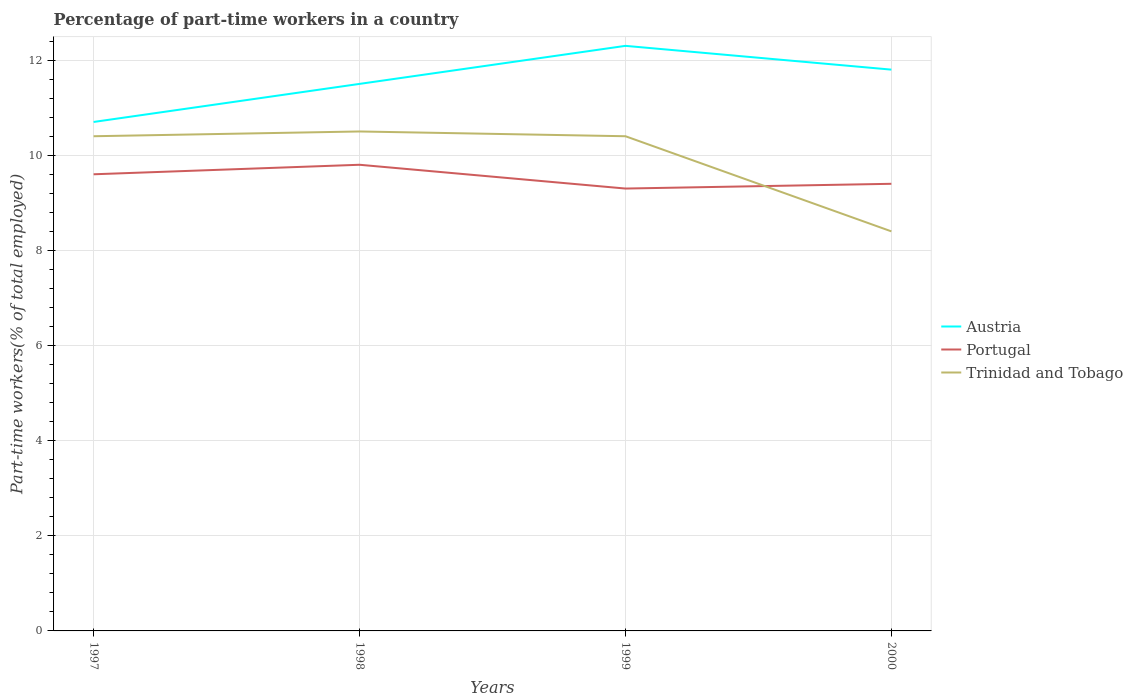How many different coloured lines are there?
Offer a very short reply. 3. Does the line corresponding to Trinidad and Tobago intersect with the line corresponding to Portugal?
Offer a terse response. Yes. Is the number of lines equal to the number of legend labels?
Provide a succinct answer. Yes. Across all years, what is the maximum percentage of part-time workers in Portugal?
Offer a terse response. 9.3. In which year was the percentage of part-time workers in Trinidad and Tobago maximum?
Your response must be concise. 2000. What is the total percentage of part-time workers in Portugal in the graph?
Ensure brevity in your answer.  0.2. What is the difference between the highest and the second highest percentage of part-time workers in Austria?
Offer a terse response. 1.6. Is the percentage of part-time workers in Austria strictly greater than the percentage of part-time workers in Trinidad and Tobago over the years?
Offer a very short reply. No. How many lines are there?
Offer a very short reply. 3. How many years are there in the graph?
Offer a very short reply. 4. How are the legend labels stacked?
Your response must be concise. Vertical. What is the title of the graph?
Provide a succinct answer. Percentage of part-time workers in a country. Does "Guam" appear as one of the legend labels in the graph?
Your answer should be very brief. No. What is the label or title of the X-axis?
Provide a succinct answer. Years. What is the label or title of the Y-axis?
Your answer should be compact. Part-time workers(% of total employed). What is the Part-time workers(% of total employed) of Austria in 1997?
Keep it short and to the point. 10.7. What is the Part-time workers(% of total employed) of Portugal in 1997?
Give a very brief answer. 9.6. What is the Part-time workers(% of total employed) of Trinidad and Tobago in 1997?
Offer a terse response. 10.4. What is the Part-time workers(% of total employed) of Austria in 1998?
Your answer should be very brief. 11.5. What is the Part-time workers(% of total employed) of Portugal in 1998?
Offer a very short reply. 9.8. What is the Part-time workers(% of total employed) in Trinidad and Tobago in 1998?
Provide a short and direct response. 10.5. What is the Part-time workers(% of total employed) of Austria in 1999?
Provide a succinct answer. 12.3. What is the Part-time workers(% of total employed) in Portugal in 1999?
Offer a terse response. 9.3. What is the Part-time workers(% of total employed) in Trinidad and Tobago in 1999?
Provide a short and direct response. 10.4. What is the Part-time workers(% of total employed) in Austria in 2000?
Ensure brevity in your answer.  11.8. What is the Part-time workers(% of total employed) in Portugal in 2000?
Make the answer very short. 9.4. What is the Part-time workers(% of total employed) of Trinidad and Tobago in 2000?
Make the answer very short. 8.4. Across all years, what is the maximum Part-time workers(% of total employed) of Austria?
Keep it short and to the point. 12.3. Across all years, what is the maximum Part-time workers(% of total employed) in Portugal?
Provide a succinct answer. 9.8. Across all years, what is the maximum Part-time workers(% of total employed) of Trinidad and Tobago?
Offer a terse response. 10.5. Across all years, what is the minimum Part-time workers(% of total employed) in Austria?
Keep it short and to the point. 10.7. Across all years, what is the minimum Part-time workers(% of total employed) of Portugal?
Ensure brevity in your answer.  9.3. Across all years, what is the minimum Part-time workers(% of total employed) of Trinidad and Tobago?
Your response must be concise. 8.4. What is the total Part-time workers(% of total employed) of Austria in the graph?
Give a very brief answer. 46.3. What is the total Part-time workers(% of total employed) of Portugal in the graph?
Provide a succinct answer. 38.1. What is the total Part-time workers(% of total employed) in Trinidad and Tobago in the graph?
Your answer should be compact. 39.7. What is the difference between the Part-time workers(% of total employed) in Austria in 1997 and that in 1998?
Ensure brevity in your answer.  -0.8. What is the difference between the Part-time workers(% of total employed) in Austria in 1997 and that in 1999?
Make the answer very short. -1.6. What is the difference between the Part-time workers(% of total employed) in Portugal in 1997 and that in 1999?
Offer a very short reply. 0.3. What is the difference between the Part-time workers(% of total employed) of Trinidad and Tobago in 1997 and that in 1999?
Make the answer very short. 0. What is the difference between the Part-time workers(% of total employed) of Austria in 1997 and that in 2000?
Offer a very short reply. -1.1. What is the difference between the Part-time workers(% of total employed) in Austria in 1998 and that in 1999?
Ensure brevity in your answer.  -0.8. What is the difference between the Part-time workers(% of total employed) in Trinidad and Tobago in 1998 and that in 2000?
Your answer should be very brief. 2.1. What is the difference between the Part-time workers(% of total employed) of Portugal in 1999 and that in 2000?
Provide a succinct answer. -0.1. What is the difference between the Part-time workers(% of total employed) of Trinidad and Tobago in 1999 and that in 2000?
Ensure brevity in your answer.  2. What is the difference between the Part-time workers(% of total employed) of Austria in 1997 and the Part-time workers(% of total employed) of Trinidad and Tobago in 1999?
Your response must be concise. 0.3. What is the difference between the Part-time workers(% of total employed) in Austria in 1997 and the Part-time workers(% of total employed) in Portugal in 2000?
Your answer should be very brief. 1.3. What is the difference between the Part-time workers(% of total employed) in Austria in 1997 and the Part-time workers(% of total employed) in Trinidad and Tobago in 2000?
Make the answer very short. 2.3. What is the difference between the Part-time workers(% of total employed) in Austria in 1998 and the Part-time workers(% of total employed) in Trinidad and Tobago in 2000?
Make the answer very short. 3.1. What is the difference between the Part-time workers(% of total employed) of Portugal in 1998 and the Part-time workers(% of total employed) of Trinidad and Tobago in 2000?
Your answer should be compact. 1.4. What is the difference between the Part-time workers(% of total employed) of Austria in 1999 and the Part-time workers(% of total employed) of Portugal in 2000?
Offer a terse response. 2.9. What is the difference between the Part-time workers(% of total employed) in Portugal in 1999 and the Part-time workers(% of total employed) in Trinidad and Tobago in 2000?
Give a very brief answer. 0.9. What is the average Part-time workers(% of total employed) of Austria per year?
Your answer should be compact. 11.57. What is the average Part-time workers(% of total employed) of Portugal per year?
Make the answer very short. 9.53. What is the average Part-time workers(% of total employed) in Trinidad and Tobago per year?
Offer a very short reply. 9.93. In the year 1997, what is the difference between the Part-time workers(% of total employed) of Austria and Part-time workers(% of total employed) of Trinidad and Tobago?
Offer a terse response. 0.3. In the year 1998, what is the difference between the Part-time workers(% of total employed) in Austria and Part-time workers(% of total employed) in Portugal?
Provide a short and direct response. 1.7. In the year 1999, what is the difference between the Part-time workers(% of total employed) of Portugal and Part-time workers(% of total employed) of Trinidad and Tobago?
Provide a short and direct response. -1.1. In the year 2000, what is the difference between the Part-time workers(% of total employed) in Austria and Part-time workers(% of total employed) in Portugal?
Your answer should be compact. 2.4. What is the ratio of the Part-time workers(% of total employed) of Austria in 1997 to that in 1998?
Keep it short and to the point. 0.93. What is the ratio of the Part-time workers(% of total employed) in Portugal in 1997 to that in 1998?
Keep it short and to the point. 0.98. What is the ratio of the Part-time workers(% of total employed) in Trinidad and Tobago in 1997 to that in 1998?
Keep it short and to the point. 0.99. What is the ratio of the Part-time workers(% of total employed) in Austria in 1997 to that in 1999?
Make the answer very short. 0.87. What is the ratio of the Part-time workers(% of total employed) in Portugal in 1997 to that in 1999?
Keep it short and to the point. 1.03. What is the ratio of the Part-time workers(% of total employed) of Trinidad and Tobago in 1997 to that in 1999?
Make the answer very short. 1. What is the ratio of the Part-time workers(% of total employed) of Austria in 1997 to that in 2000?
Ensure brevity in your answer.  0.91. What is the ratio of the Part-time workers(% of total employed) in Portugal in 1997 to that in 2000?
Offer a terse response. 1.02. What is the ratio of the Part-time workers(% of total employed) in Trinidad and Tobago in 1997 to that in 2000?
Give a very brief answer. 1.24. What is the ratio of the Part-time workers(% of total employed) of Austria in 1998 to that in 1999?
Give a very brief answer. 0.94. What is the ratio of the Part-time workers(% of total employed) of Portugal in 1998 to that in 1999?
Your response must be concise. 1.05. What is the ratio of the Part-time workers(% of total employed) in Trinidad and Tobago in 1998 to that in 1999?
Provide a short and direct response. 1.01. What is the ratio of the Part-time workers(% of total employed) of Austria in 1998 to that in 2000?
Provide a short and direct response. 0.97. What is the ratio of the Part-time workers(% of total employed) in Portugal in 1998 to that in 2000?
Ensure brevity in your answer.  1.04. What is the ratio of the Part-time workers(% of total employed) of Austria in 1999 to that in 2000?
Offer a very short reply. 1.04. What is the ratio of the Part-time workers(% of total employed) of Portugal in 1999 to that in 2000?
Provide a succinct answer. 0.99. What is the ratio of the Part-time workers(% of total employed) in Trinidad and Tobago in 1999 to that in 2000?
Offer a very short reply. 1.24. What is the difference between the highest and the second highest Part-time workers(% of total employed) in Trinidad and Tobago?
Keep it short and to the point. 0.1. What is the difference between the highest and the lowest Part-time workers(% of total employed) of Austria?
Provide a succinct answer. 1.6. What is the difference between the highest and the lowest Part-time workers(% of total employed) in Portugal?
Your response must be concise. 0.5. 